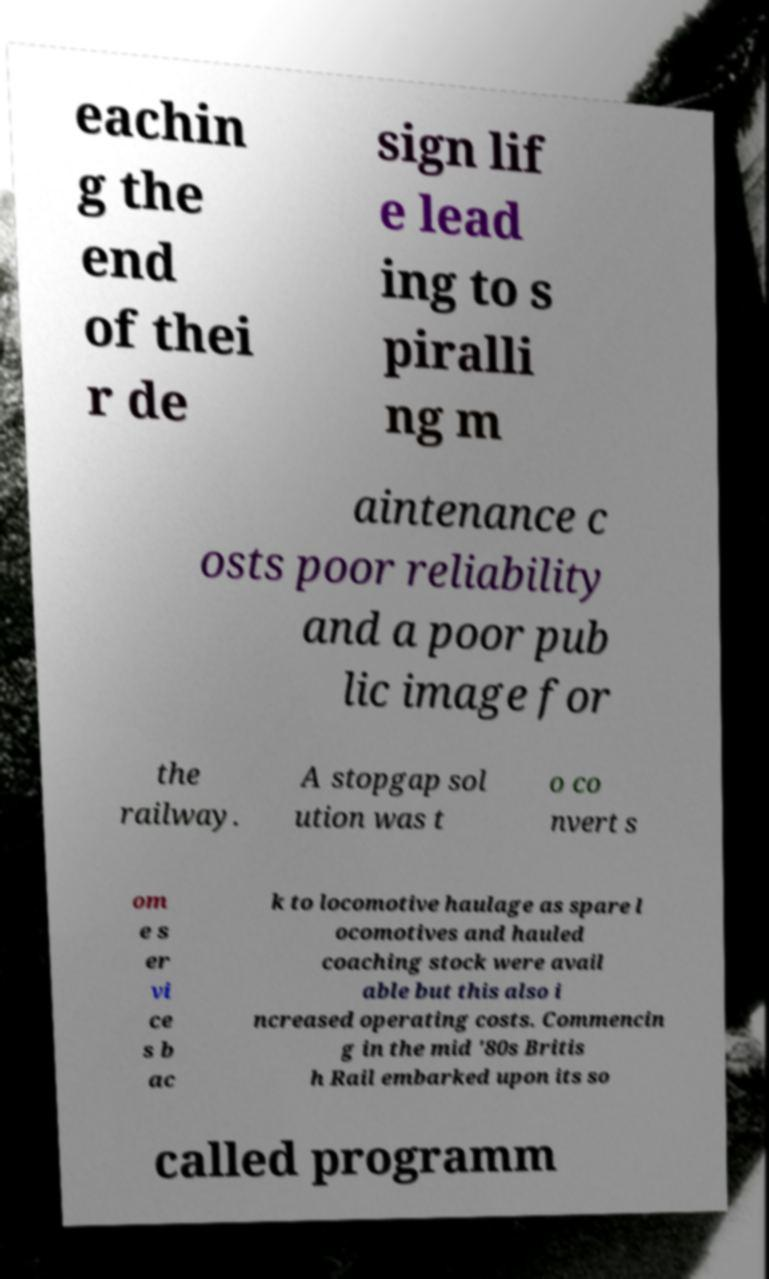There's text embedded in this image that I need extracted. Can you transcribe it verbatim? eachin g the end of thei r de sign lif e lead ing to s piralli ng m aintenance c osts poor reliability and a poor pub lic image for the railway. A stopgap sol ution was t o co nvert s om e s er vi ce s b ac k to locomotive haulage as spare l ocomotives and hauled coaching stock were avail able but this also i ncreased operating costs. Commencin g in the mid '80s Britis h Rail embarked upon its so called programm 